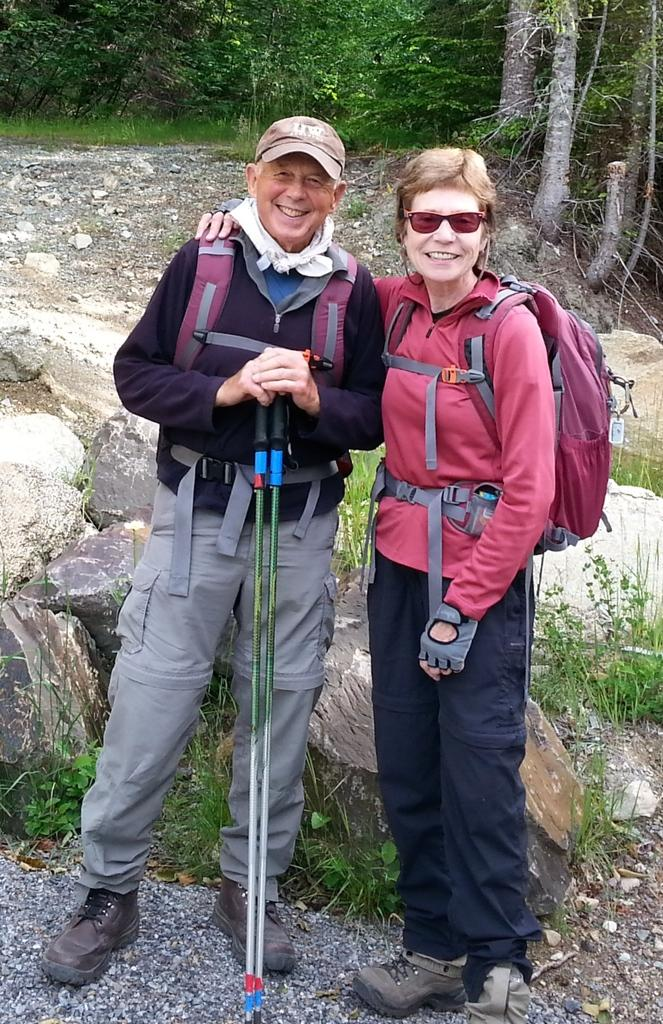Who is present in the image? There is a person in the image. Can you describe the person in the image? There is a lady in the image. What is the lady holding in her hand? The lady is holding two sticks in her hand. What can be seen in the background of the image? There are trees in the background of the image. How many pencils are visible in the image? There are no pencils present in the image. What type of yam is being prepared by the lady in the image? There is no yam or any indication of food preparation in the image. 